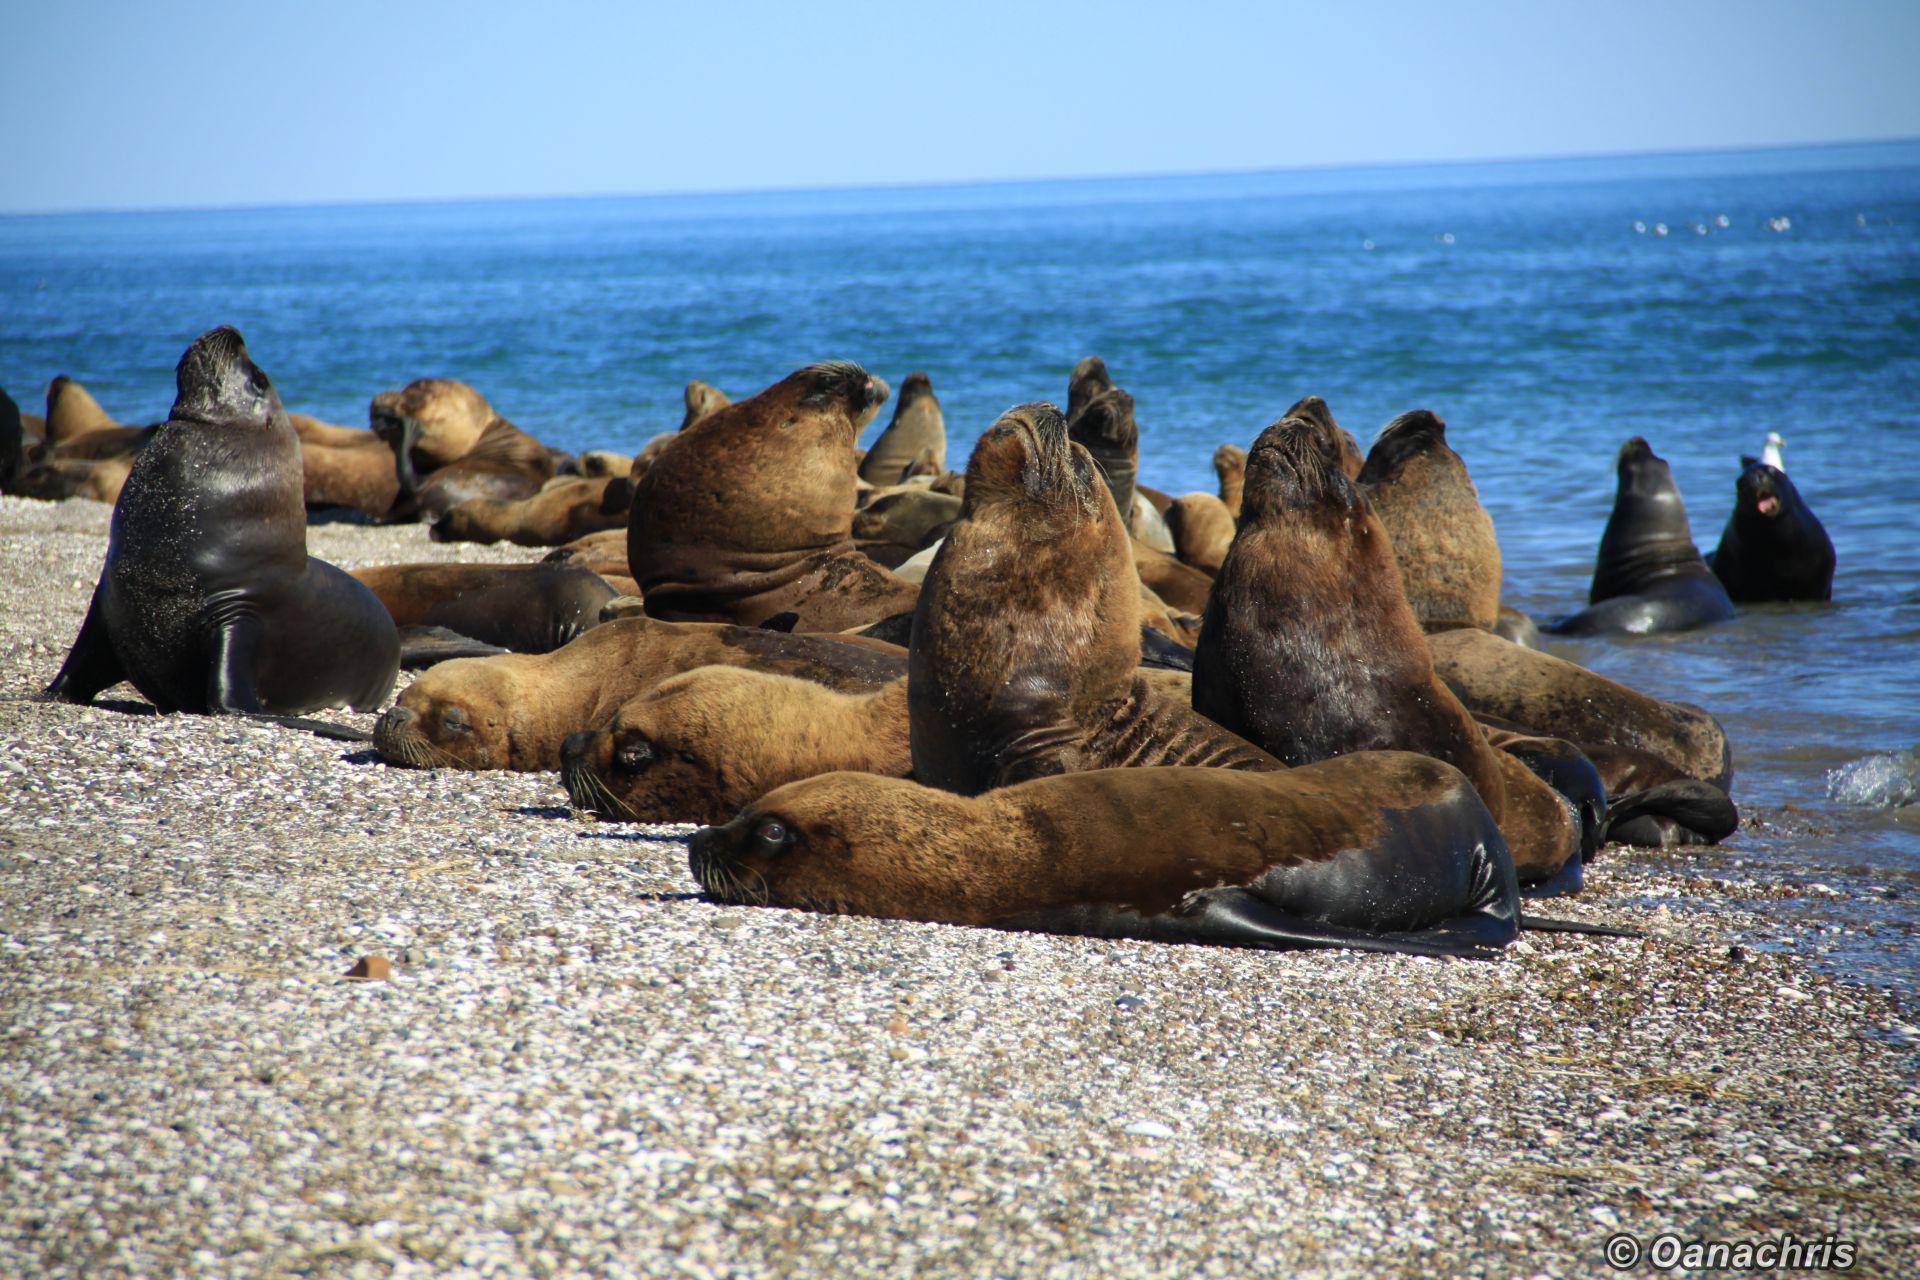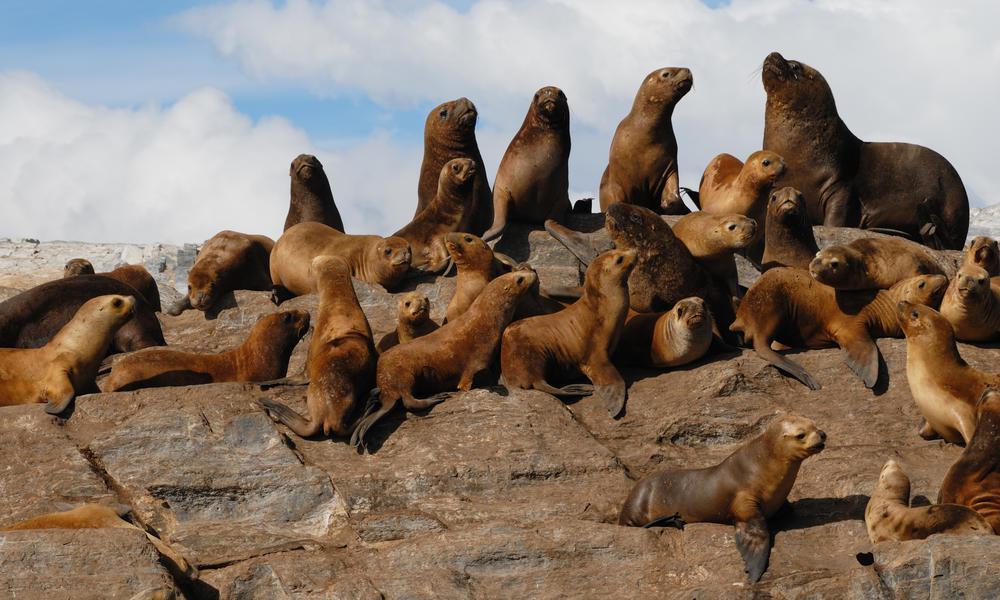The first image is the image on the left, the second image is the image on the right. Given the left and right images, does the statement "There is no land on the horizon of the image on the left." hold true? Answer yes or no. Yes. 